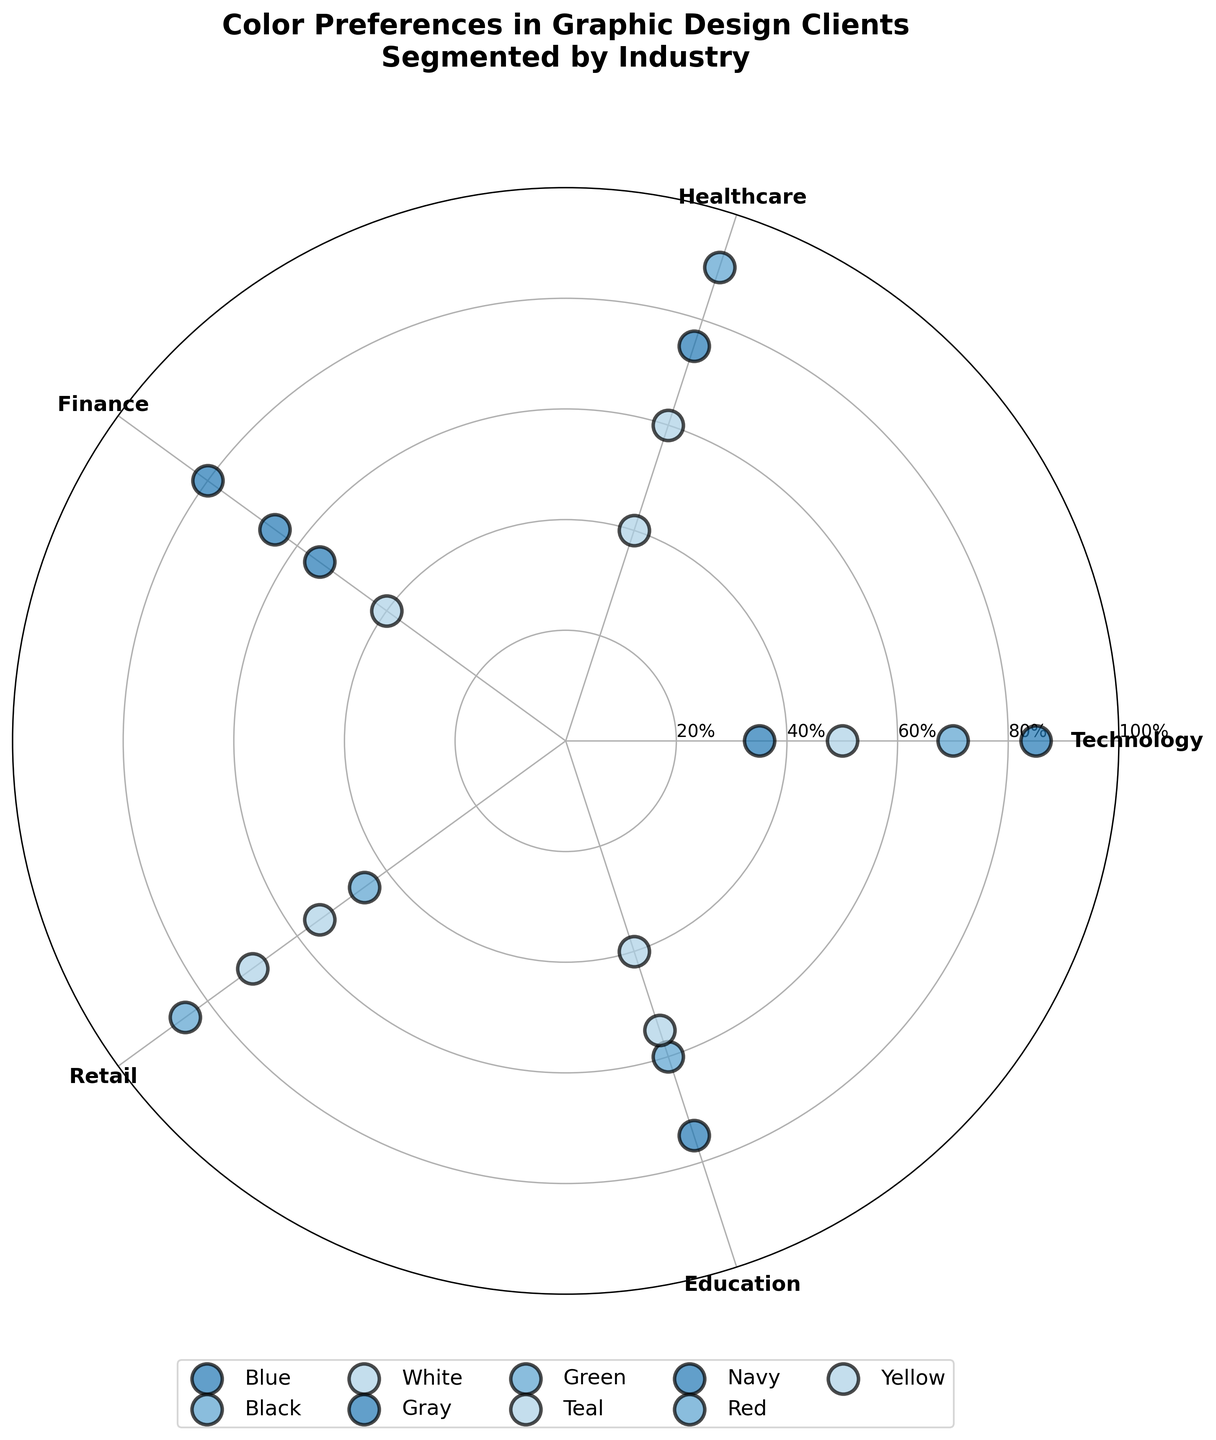What is the title of the chart? The title is prominently displayed at the top of the figure. It summarizes what the chart is about.
Answer: "Color Preferences in Graphic Design Clients Segmented by Industry" Which industry prefers the color Green the most? You need to find the data points marked in green and identify which industry has the highest preference score for green.
Answer: Healthcare How many unique colors are plotted on the chart? Look at the legend to see how many different colors are listed. Each color represents a unique entry.
Answer: 9 What's the preference score of the color Blue in the Finance industry? Locate the data point corresponding to 'Blue' in the Finance industry and read off its preference score.
Answer: 80 Which color in the Education industry has the lowest preference score? Identify the data points for Education and find the one with the smallest radial (outward) distance representing the score.
Answer: White Compare the preference scores of the color White between Technology and Retail industries. Which industry has a higher score? Locate the 'White' data points for both Technology and Retail and compare their radial distances.
Answer: Retail What’s the average preference score of the colors in the Retail industry? Sum the preference scores for all colors in the Retail industry and divide by the total number of colors.
Answer: (85 + 70 + 55 + 45) / 4 = 63.75 How many colors have a preference score above 70 in the Healthcare industry? Look at the Healthcare data points and count how many have radial distances above 70.
Answer: 2 Which color appears in the highest number of industries? Check the legend and match each color with industries on the radial axis. Count the occurrences.
Answer: White Between Healthcare and Finance, which industry has a higher overall preference score for the color Blue? Compare the radial distances (preference scores) of the blue data points in Healthcare and Finance.
Answer: Healthcare 